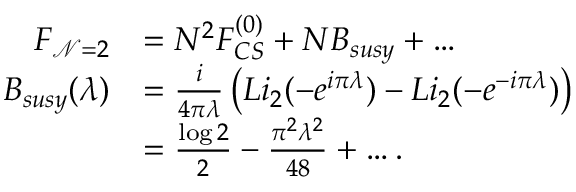Convert formula to latex. <formula><loc_0><loc_0><loc_500><loc_500>\begin{array} { r l } { F _ { \mathcal { N } = 2 } } & { = N ^ { 2 } F _ { C S } ^ { ( 0 ) } + N B _ { s u s y } + \dots } \\ { B _ { s u s y } ( \lambda ) } & { = \frac { i } { 4 \pi \lambda } \left ( L i _ { 2 } ( - e ^ { i \pi \lambda } ) - L i _ { 2 } ( - e ^ { - i \pi \lambda } ) \right ) } \\ & { = \frac { \log 2 } { 2 } - \frac { \pi ^ { 2 } \lambda ^ { 2 } } { 4 8 } + \dots . } \end{array}</formula> 